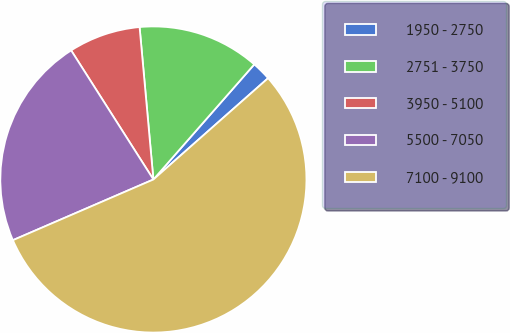<chart> <loc_0><loc_0><loc_500><loc_500><pie_chart><fcel>1950 - 2750<fcel>2751 - 3750<fcel>3950 - 5100<fcel>5500 - 7050<fcel>7100 - 9100<nl><fcel>2.03%<fcel>12.89%<fcel>7.59%<fcel>22.46%<fcel>55.02%<nl></chart> 